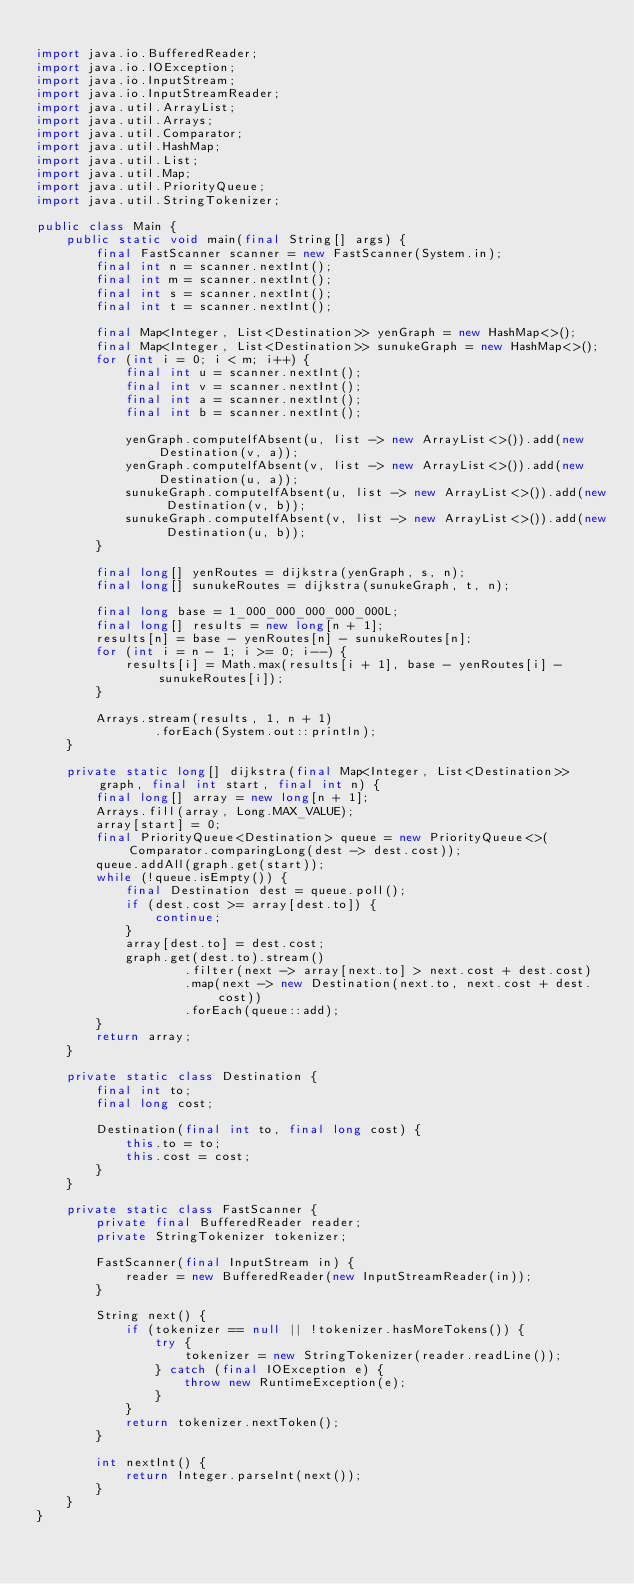Convert code to text. <code><loc_0><loc_0><loc_500><loc_500><_Java_>
import java.io.BufferedReader;
import java.io.IOException;
import java.io.InputStream;
import java.io.InputStreamReader;
import java.util.ArrayList;
import java.util.Arrays;
import java.util.Comparator;
import java.util.HashMap;
import java.util.List;
import java.util.Map;
import java.util.PriorityQueue;
import java.util.StringTokenizer;

public class Main {
    public static void main(final String[] args) {
        final FastScanner scanner = new FastScanner(System.in);
        final int n = scanner.nextInt();
        final int m = scanner.nextInt();
        final int s = scanner.nextInt();
        final int t = scanner.nextInt();

        final Map<Integer, List<Destination>> yenGraph = new HashMap<>();
        final Map<Integer, List<Destination>> sunukeGraph = new HashMap<>();
        for (int i = 0; i < m; i++) {
            final int u = scanner.nextInt();
            final int v = scanner.nextInt();
            final int a = scanner.nextInt();
            final int b = scanner.nextInt();

            yenGraph.computeIfAbsent(u, list -> new ArrayList<>()).add(new Destination(v, a));
            yenGraph.computeIfAbsent(v, list -> new ArrayList<>()).add(new Destination(u, a));
            sunukeGraph.computeIfAbsent(u, list -> new ArrayList<>()).add(new Destination(v, b));
            sunukeGraph.computeIfAbsent(v, list -> new ArrayList<>()).add(new Destination(u, b));
        }

        final long[] yenRoutes = dijkstra(yenGraph, s, n);
        final long[] sunukeRoutes = dijkstra(sunukeGraph, t, n);

        final long base = 1_000_000_000_000_000L;
        final long[] results = new long[n + 1];
        results[n] = base - yenRoutes[n] - sunukeRoutes[n];
        for (int i = n - 1; i >= 0; i--) {
            results[i] = Math.max(results[i + 1], base - yenRoutes[i] - sunukeRoutes[i]);
        }

        Arrays.stream(results, 1, n + 1)
                .forEach(System.out::println);
    }

    private static long[] dijkstra(final Map<Integer, List<Destination>> graph, final int start, final int n) {
        final long[] array = new long[n + 1];
        Arrays.fill(array, Long.MAX_VALUE);
        array[start] = 0;
        final PriorityQueue<Destination> queue = new PriorityQueue<>(Comparator.comparingLong(dest -> dest.cost));
        queue.addAll(graph.get(start));
        while (!queue.isEmpty()) {
            final Destination dest = queue.poll();
            if (dest.cost >= array[dest.to]) {
                continue;
            }
            array[dest.to] = dest.cost;
            graph.get(dest.to).stream()
                    .filter(next -> array[next.to] > next.cost + dest.cost)
                    .map(next -> new Destination(next.to, next.cost + dest.cost))
                    .forEach(queue::add);
        }
        return array;
    }

    private static class Destination {
        final int to;
        final long cost;

        Destination(final int to, final long cost) {
            this.to = to;
            this.cost = cost;
        }
    }

    private static class FastScanner {
        private final BufferedReader reader;
        private StringTokenizer tokenizer;

        FastScanner(final InputStream in) {
            reader = new BufferedReader(new InputStreamReader(in));
        }

        String next() {
            if (tokenizer == null || !tokenizer.hasMoreTokens()) {
                try {
                    tokenizer = new StringTokenizer(reader.readLine());
                } catch (final IOException e) {
                    throw new RuntimeException(e);
                }
            }
            return tokenizer.nextToken();
        }

        int nextInt() {
            return Integer.parseInt(next());
        }
    }
}
    </code> 